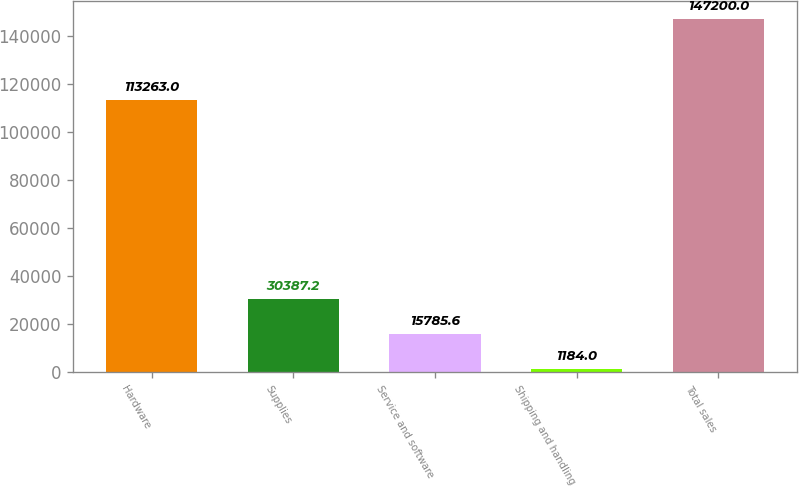Convert chart to OTSL. <chart><loc_0><loc_0><loc_500><loc_500><bar_chart><fcel>Hardware<fcel>Supplies<fcel>Service and software<fcel>Shipping and handling<fcel>Total sales<nl><fcel>113263<fcel>30387.2<fcel>15785.6<fcel>1184<fcel>147200<nl></chart> 